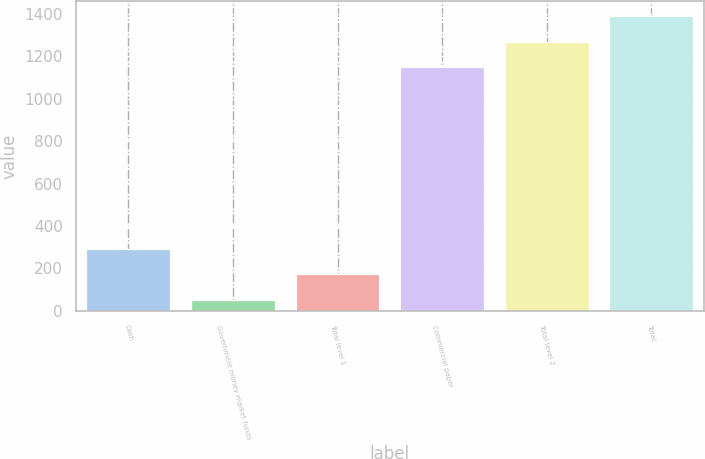Convert chart to OTSL. <chart><loc_0><loc_0><loc_500><loc_500><bar_chart><fcel>Cash<fcel>Government money market funds<fcel>Total level 1<fcel>Commercial paper<fcel>Total level 2<fcel>Total<nl><fcel>292.8<fcel>50<fcel>171.4<fcel>1147<fcel>1268.4<fcel>1389.8<nl></chart> 